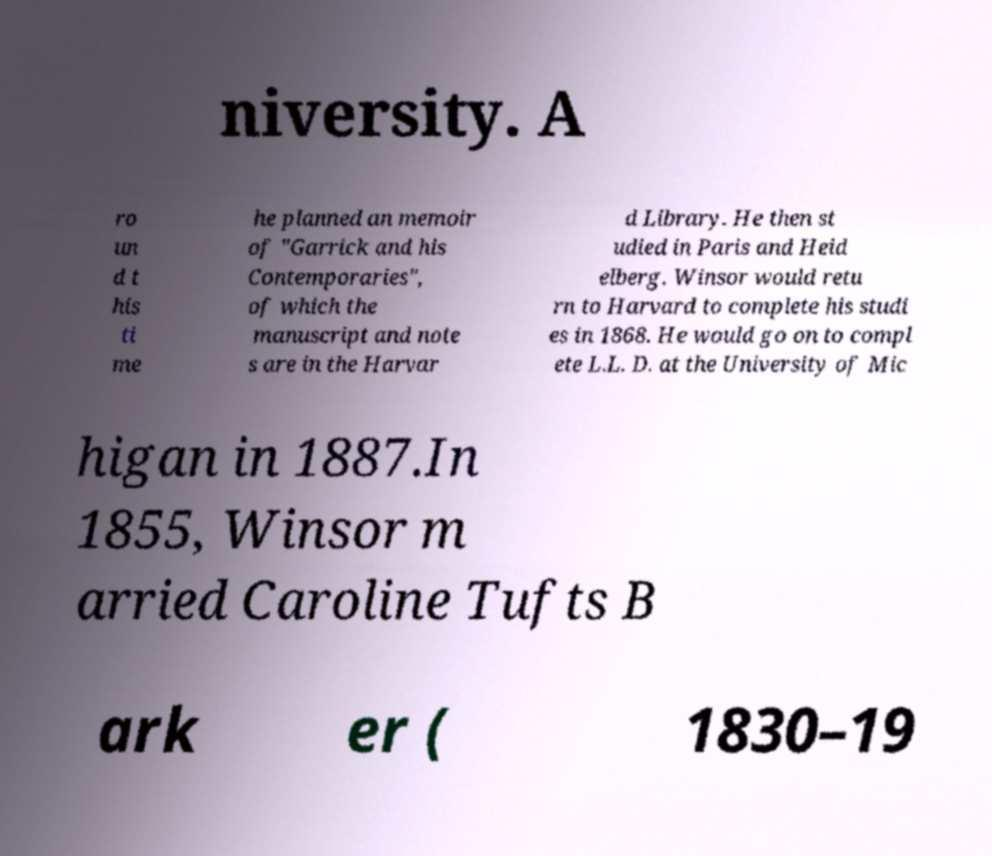Could you extract and type out the text from this image? niversity. A ro un d t his ti me he planned an memoir of "Garrick and his Contemporaries", of which the manuscript and note s are in the Harvar d Library. He then st udied in Paris and Heid elberg. Winsor would retu rn to Harvard to complete his studi es in 1868. He would go on to compl ete L.L. D. at the University of Mic higan in 1887.In 1855, Winsor m arried Caroline Tufts B ark er ( 1830–19 